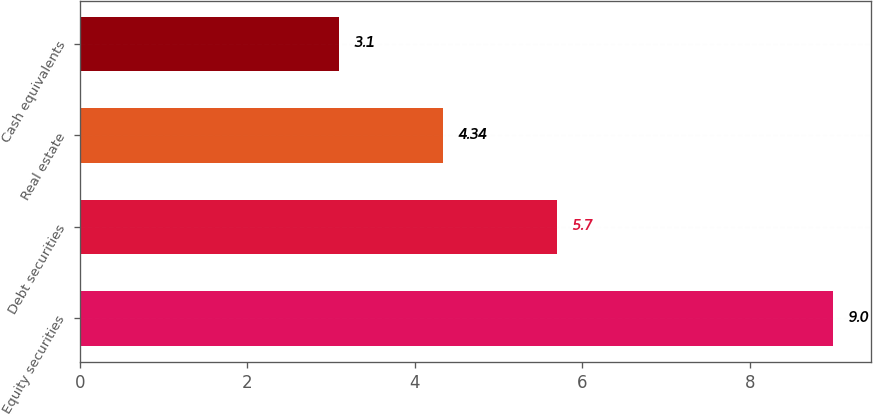Convert chart. <chart><loc_0><loc_0><loc_500><loc_500><bar_chart><fcel>Equity securities<fcel>Debt securities<fcel>Real estate<fcel>Cash equivalents<nl><fcel>9<fcel>5.7<fcel>4.34<fcel>3.1<nl></chart> 